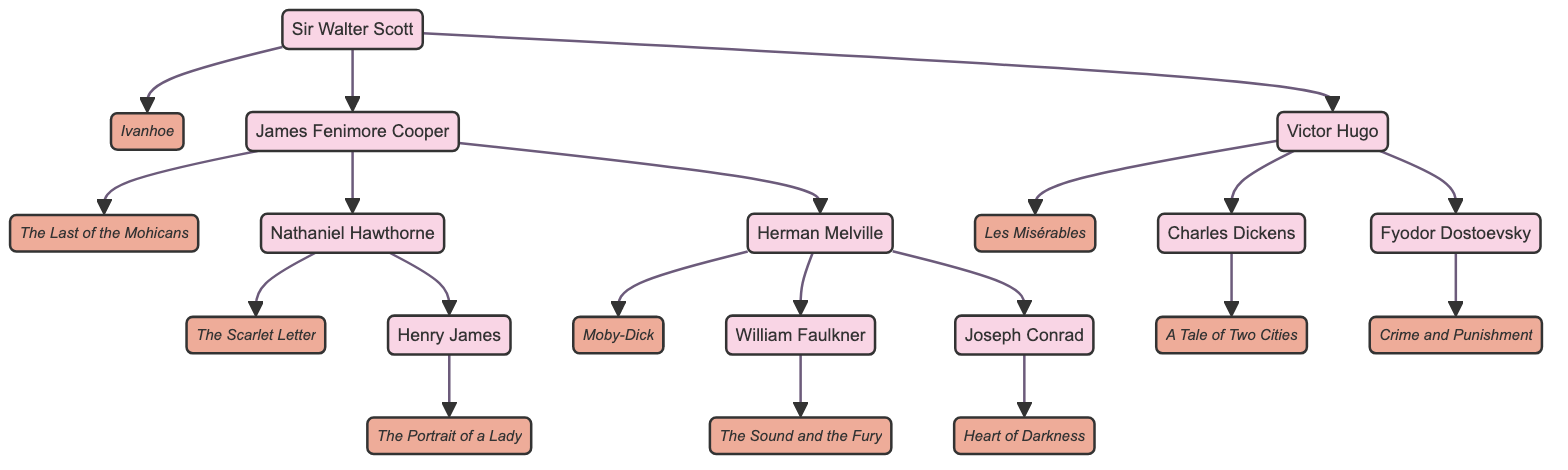What is the most famous work of Sir Walter Scott? The diagram shows that Sir Walter Scott's most famous work is linked directly to him, and it is labeled as "Ivanhoe"
Answer: Ivanhoe Who influenced Victor Hugo? By examining the diagram, it is clear that Victor Hugo is influenced by Sir Walter Scott, as indicated by the arrow connecting them with Scott's name at the input end
Answer: Sir Walter Scott How many authors are influenced by James Fenimore Cooper? The diagram shows that there are two authors influenced by James Fenimore Cooper: Nathaniel Hawthorne and Herman Melville
Answer: 2 What is the relationship between Herman Melville and William Faulkner? The diagram shows that Herman Melville is an influential figure for William Faulkner, indicated by the directional arrow from Melville to Faulkner
Answer: Influenced Which author has the most influences listed? By counting the literary influences for each author, it is evident that Herman Melville has two listed influences: James Fenimore Cooper and Nathaniel Hawthorne
Answer: Herman Melville What is the most famous work of Nathaniel Hawthorne? The diagram associates Nathaniel Hawthorne with his most famous work, which is stated as "The Scarlet Letter," directly linked to his node
Answer: The Scarlet Letter Which author is at the top of the lineage in this family tree? The diagram positions Sir Walter Scott at the top, indicating he is the starting point or ancestor of the other authors below him
Answer: Sir Walter Scott How many edges (relationships) are there between all authors in total? By counting the arrows in the diagram, we can see that there are ten distinct relationships connecting different authors
Answer: 10 Which author's most famous work directly influenced Charles Dickens? The diagram reveals that Victor Hugo, whose most famous work is "Les Misérables," directly influenced Charles Dickens as shown by the connecting arrow
Answer: Victor Hugo 